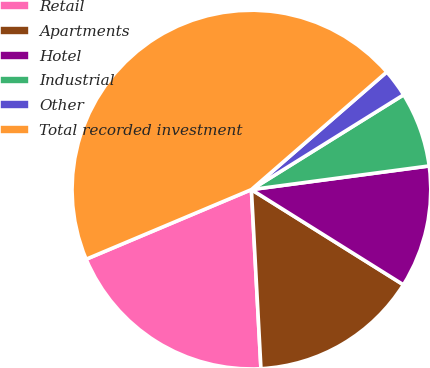Convert chart. <chart><loc_0><loc_0><loc_500><loc_500><pie_chart><fcel>Retail<fcel>Apartments<fcel>Hotel<fcel>Industrial<fcel>Other<fcel>Total recorded investment<nl><fcel>19.5%<fcel>15.25%<fcel>11.01%<fcel>6.76%<fcel>2.52%<fcel>44.96%<nl></chart> 